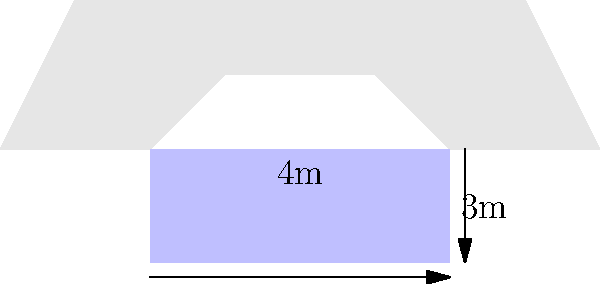A firefighting helicopter is equipped with a rectangular water tank for aerial firefighting operations. The tank measures 4 meters in length and 3 meters in height. If the tank is filled to 80% of its capacity, and water has a density of 1000 kg/m³, what is the additional weight the helicopter must carry? Assume the tank width is 2 meters. To solve this problem, we'll follow these steps:

1. Calculate the total volume of the tank:
   $V_{total} = length \times width \times height$
   $V_{total} = 4\text{ m} \times 2\text{ m} \times 3\text{ m} = 24\text{ m}^3$

2. Calculate the volume of water at 80% capacity:
   $V_{water} = 80\% \times V_{total} = 0.8 \times 24\text{ m}^3 = 19.2\text{ m}^3$

3. Calculate the mass of water using its density:
   $m_{water} = \rho_{water} \times V_{water}$
   $m_{water} = 1000\text{ kg/m}^3 \times 19.2\text{ m}^3 = 19,200\text{ kg}$

4. Convert the mass to weight (considering standard gravity, $g = 9.81\text{ m/s}^2$):
   $W_{water} = m_{water} \times g$
   $W_{water} = 19,200\text{ kg} \times 9.81\text{ m/s}^2 = 188,352\text{ N}$

Therefore, the additional weight the helicopter must carry is approximately 188,352 N or 188.4 kN.
Answer: 188.4 kN 